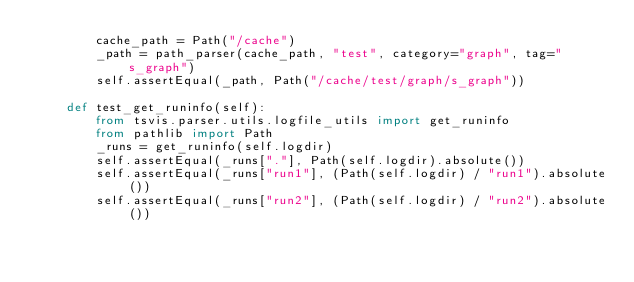Convert code to text. <code><loc_0><loc_0><loc_500><loc_500><_Python_>        cache_path = Path("/cache")
        _path = path_parser(cache_path, "test", category="graph", tag="s_graph")
        self.assertEqual(_path, Path("/cache/test/graph/s_graph"))

    def test_get_runinfo(self):
        from tsvis.parser.utils.logfile_utils import get_runinfo
        from pathlib import Path
        _runs = get_runinfo(self.logdir)
        self.assertEqual(_runs["."], Path(self.logdir).absolute())
        self.assertEqual(_runs["run1"], (Path(self.logdir) / "run1").absolute())
        self.assertEqual(_runs["run2"], (Path(self.logdir) / "run2").absolute())
</code> 